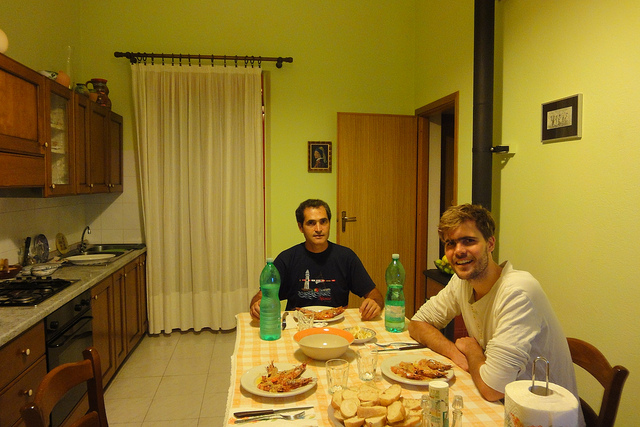<image>Where is the pterodactyl? I don't know where the pterodactyl is. It might be on the table or outside, or there might not be one at all. Where is the pterodactyl? I am not sure where the pterodactyl is. It can be seen on the table, on the shirt, or outside. 